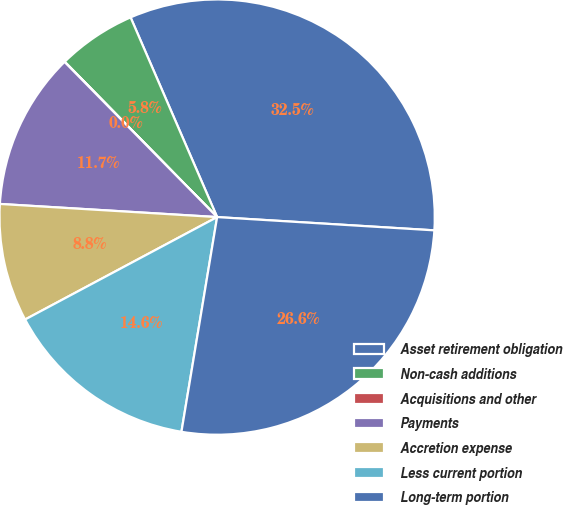<chart> <loc_0><loc_0><loc_500><loc_500><pie_chart><fcel>Asset retirement obligation<fcel>Non-cash additions<fcel>Acquisitions and other<fcel>Payments<fcel>Accretion expense<fcel>Less current portion<fcel>Long-term portion<nl><fcel>32.48%<fcel>5.84%<fcel>0.02%<fcel>11.67%<fcel>8.76%<fcel>14.58%<fcel>26.65%<nl></chart> 